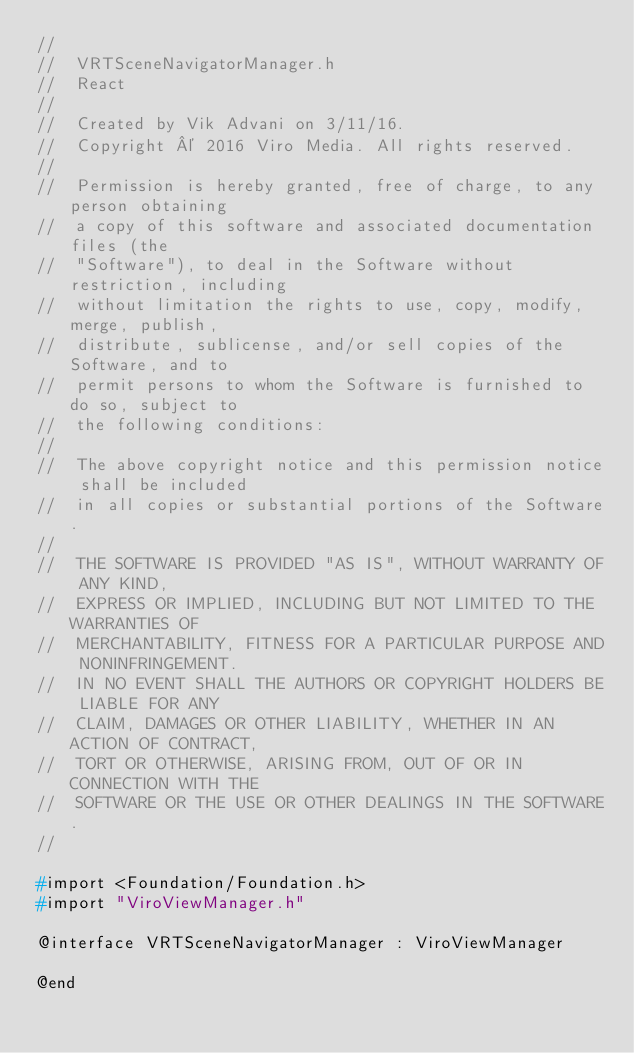<code> <loc_0><loc_0><loc_500><loc_500><_C_>//
//  VRTSceneNavigatorManager.h
//  React
//
//  Created by Vik Advani on 3/11/16.
//  Copyright © 2016 Viro Media. All rights reserved.
//
//  Permission is hereby granted, free of charge, to any person obtaining
//  a copy of this software and associated documentation files (the
//  "Software"), to deal in the Software without restriction, including
//  without limitation the rights to use, copy, modify, merge, publish,
//  distribute, sublicense, and/or sell copies of the Software, and to
//  permit persons to whom the Software is furnished to do so, subject to
//  the following conditions:
//
//  The above copyright notice and this permission notice shall be included
//  in all copies or substantial portions of the Software.
//
//  THE SOFTWARE IS PROVIDED "AS IS", WITHOUT WARRANTY OF ANY KIND,
//  EXPRESS OR IMPLIED, INCLUDING BUT NOT LIMITED TO THE WARRANTIES OF
//  MERCHANTABILITY, FITNESS FOR A PARTICULAR PURPOSE AND NONINFRINGEMENT.
//  IN NO EVENT SHALL THE AUTHORS OR COPYRIGHT HOLDERS BE LIABLE FOR ANY
//  CLAIM, DAMAGES OR OTHER LIABILITY, WHETHER IN AN ACTION OF CONTRACT,
//  TORT OR OTHERWISE, ARISING FROM, OUT OF OR IN CONNECTION WITH THE
//  SOFTWARE OR THE USE OR OTHER DEALINGS IN THE SOFTWARE.
//

#import <Foundation/Foundation.h>
#import "ViroViewManager.h"

@interface VRTSceneNavigatorManager : ViroViewManager

@end
</code> 